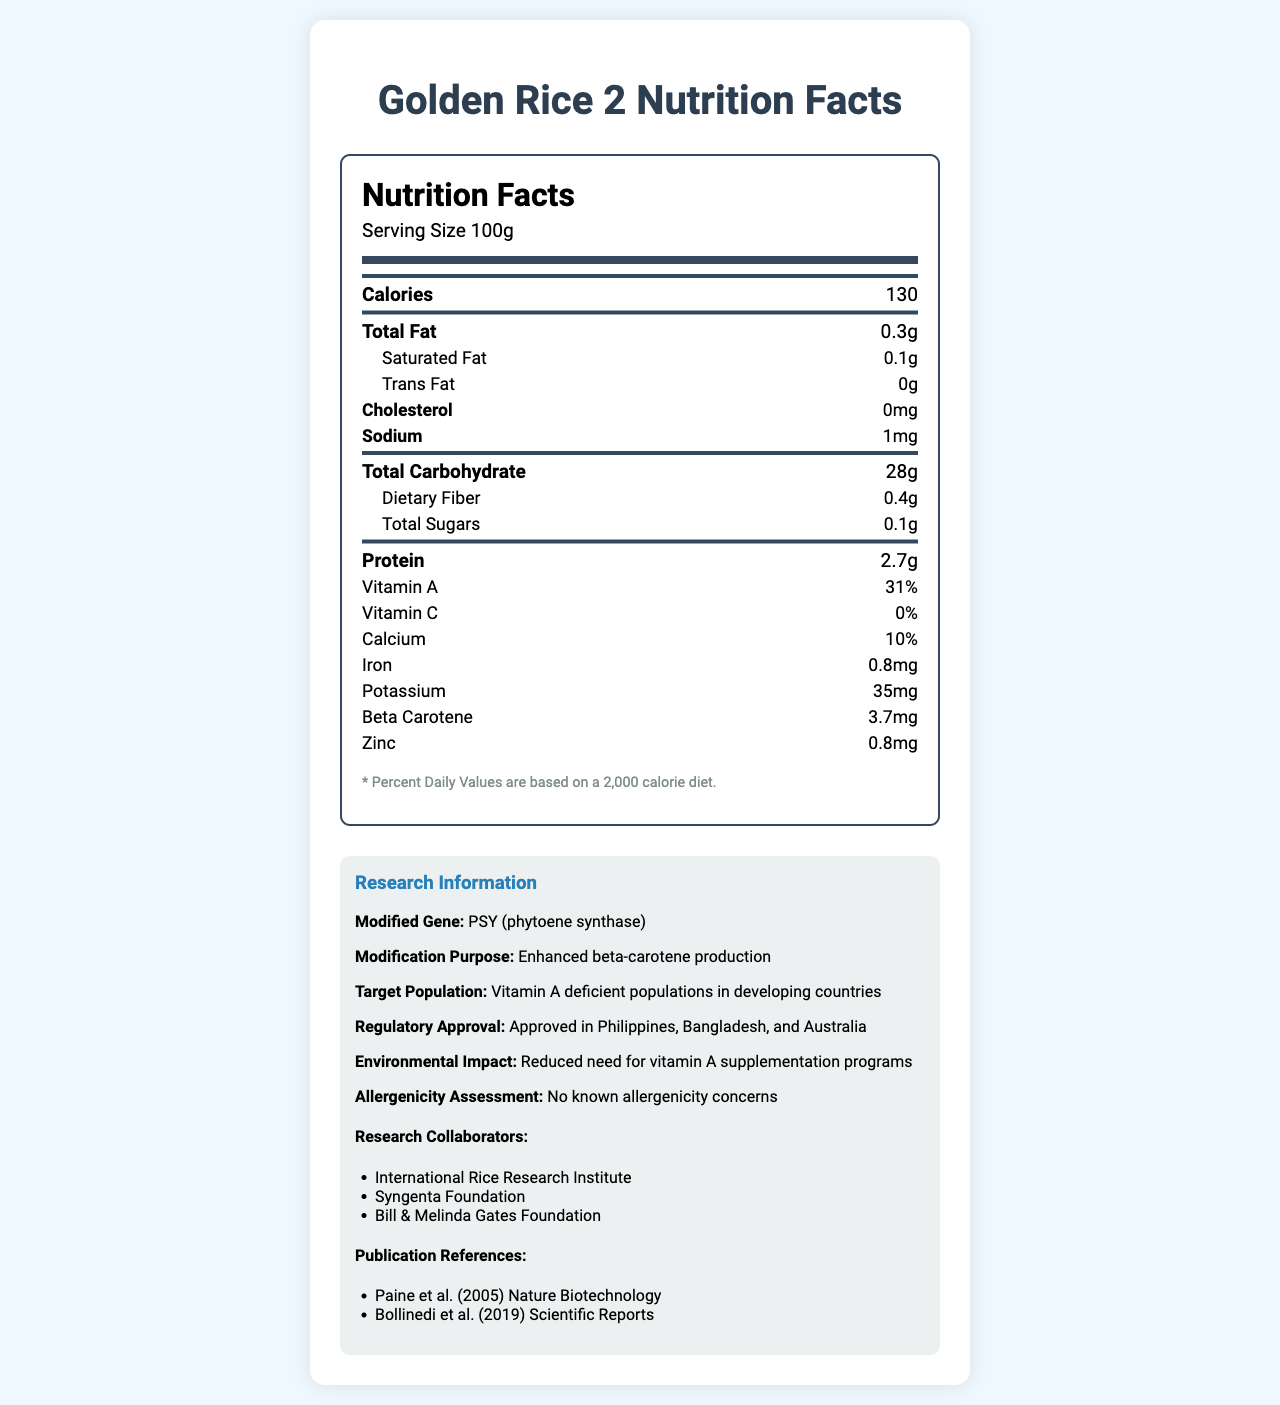what is the crop name? The crop name is listed at the top of the document as "Golden Rice 2."
Answer: Golden Rice 2 what is the serving size for Golden Rice 2? The serving size is mentioned in the sub-header of the nutrition label section.
Answer: 100g how many calories are in one serving of Golden Rice 2? The calories per serving are shown clearly under the "Calories" section.
Answer: 130 how much Vitamin A is provided in one serving? The percentage of Vitamin A is listed under the nutrient details.
Answer: 31% which specific gene has been modified in Golden Rice 2? The modified gene is mentioned in the research information section under "Modified Gene."
Answer: PSY (phytoene synthase) what is the purpose of the genetic modification of Golden Rice 2? The purpose is clearly stated in the research information section under "Modification Purpose."
Answer: Enhanced beta-carotene production in which countries has Golden Rice 2 received regulatory approval? These countries are listed under the "Regulatory Approval" section.
Answer: Philippines, Bangladesh, and Australia who are the research collaborators involved in the development of Golden Rice 2? The collaborators are listed in the "Research Collaborators" section.
Answer: International Rice Research Institute, Syngenta Foundation, Bill & Melinda Gates Foundation what is the dietary fiber content in one serving? The dietary fiber content is listed under the total carbohydrate section.
Answer: 0.4g which among the following nutrients has the highest percentage value in Golden Rice 2? A. Vitamin A B. Calcium C. Iron Vitamin A has the highest percentage value listed at 31%.
Answer: A how much protein does one serving of Golden Rice 2 contain? A. 2.7g B. 3.0g C. 2.5g D. 2.9g One serving contains 2.7g of protein.
Answer: A does Golden Rice 2 contain any trans fat? The trans fat content is listed as 0g.
Answer: No is there any information about possible allergenicity concerns for Golden Rice 2? This is explicitly stated in the allergenicity assessment section under research information.
Answer: No known allergenicity concerns summarize the main details and purpose of the provided document. The document is a comprehensive nutritional overview of Golden Rice 2, emphasizing its purpose to combat Vitamin A deficiency in developing countries through enhanced beta-carotene content. It also covers approvals, target groups, and safety information.
Answer: The document provides a detailed nutritional profile of Golden Rice 2, a genetically modified crop with enhanced beta-carotene production. It outlines various nutrients contained per 100g serving, highlights the genetic modification purpose, target population, regulatory approvals, and addresses environmental and allergenicity considerations. The document also acknowledges the research collaborators and references relevant publications. what is the impact of Golden Rice 2 on vitamin A supplementation programs? The environmental impact section mentions this specific impact.
Answer: Reduced need for vitamin A supplementation programs how much calcium is in one serving of Golden Rice 2? The calcium percentage is listed under the nutrient details.
Answer: 10% who is the target population for Golden Rice 2? This is noted in the research information section under "Target Population."
Answer: Vitamin A deficient populations in developing countries how much beta-carotene does one serving of Golden Rice 2 provide? The beta-carotene content is listed under the nutrient details.
Answer: 3.7mg how many publications are referenced in the document? The document lists two references under "Publication References."
Answer: Two when was the study by Paine et al. published? The document only lists the authors and journal title without specifying the publication date.
Answer: Cannot be determined what is the total carbohydrate content per serving? The total carbohydrate content is listed clearly under the nutrition facts.
Answer: 28g 